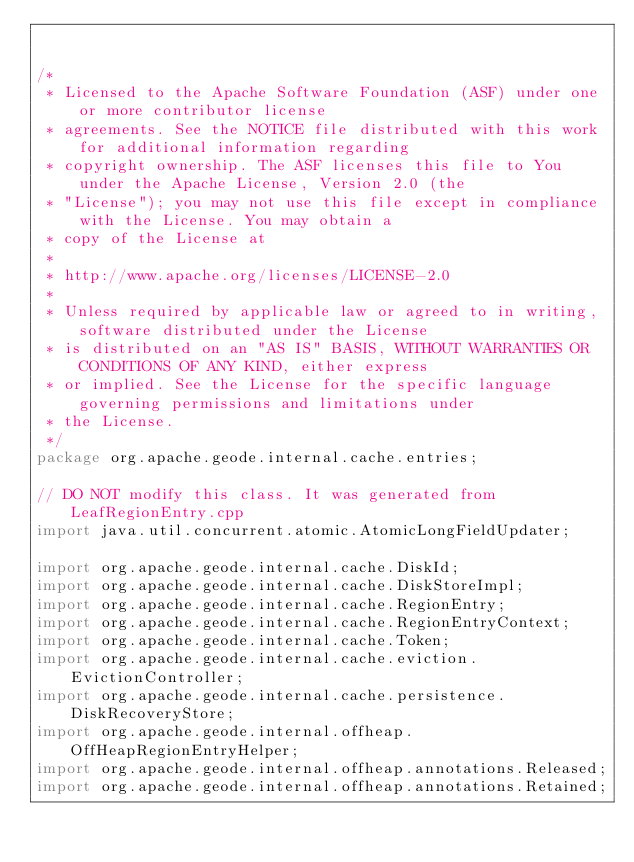Convert code to text. <code><loc_0><loc_0><loc_500><loc_500><_Java_>

/*
 * Licensed to the Apache Software Foundation (ASF) under one or more contributor license
 * agreements. See the NOTICE file distributed with this work for additional information regarding
 * copyright ownership. The ASF licenses this file to You under the Apache License, Version 2.0 (the
 * "License"); you may not use this file except in compliance with the License. You may obtain a
 * copy of the License at
 *
 * http://www.apache.org/licenses/LICENSE-2.0
 *
 * Unless required by applicable law or agreed to in writing, software distributed under the License
 * is distributed on an "AS IS" BASIS, WITHOUT WARRANTIES OR CONDITIONS OF ANY KIND, either express
 * or implied. See the License for the specific language governing permissions and limitations under
 * the License.
 */
package org.apache.geode.internal.cache.entries;

// DO NOT modify this class. It was generated from LeafRegionEntry.cpp
import java.util.concurrent.atomic.AtomicLongFieldUpdater;

import org.apache.geode.internal.cache.DiskId;
import org.apache.geode.internal.cache.DiskStoreImpl;
import org.apache.geode.internal.cache.RegionEntry;
import org.apache.geode.internal.cache.RegionEntryContext;
import org.apache.geode.internal.cache.Token;
import org.apache.geode.internal.cache.eviction.EvictionController;
import org.apache.geode.internal.cache.persistence.DiskRecoveryStore;
import org.apache.geode.internal.offheap.OffHeapRegionEntryHelper;
import org.apache.geode.internal.offheap.annotations.Released;
import org.apache.geode.internal.offheap.annotations.Retained;</code> 